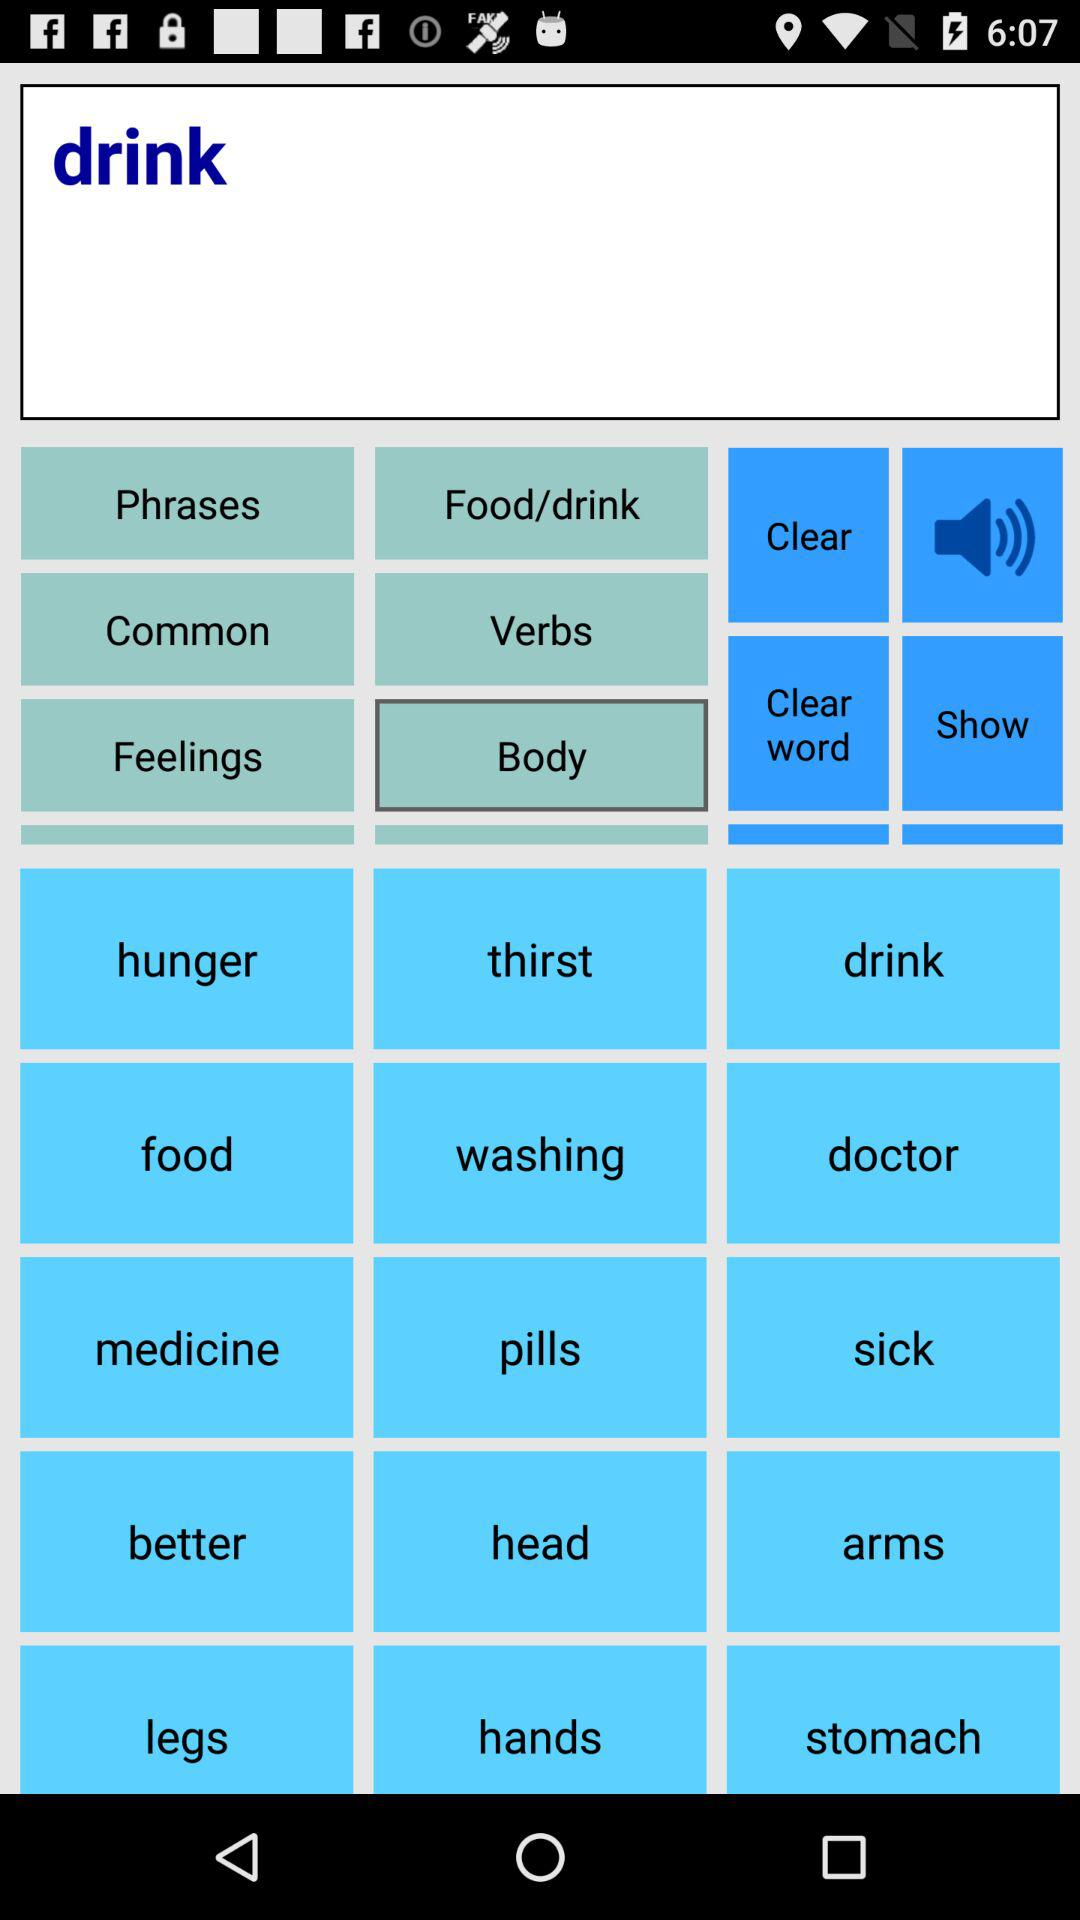What is the name of the application? The name of the application is "Speech Assistant". 